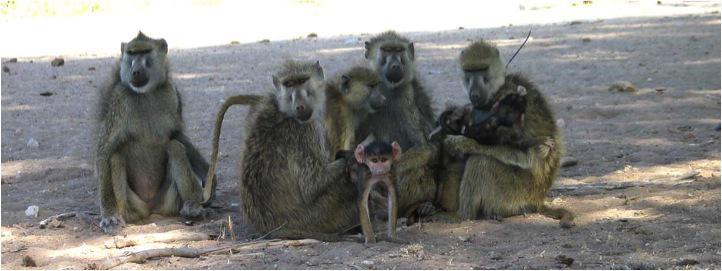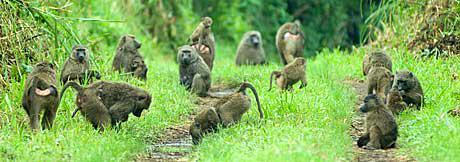The first image is the image on the left, the second image is the image on the right. Considering the images on both sides, is "One image has words." valid? Answer yes or no. No. The first image is the image on the left, the second image is the image on the right. Analyze the images presented: Is the assertion "There are monkeys sitting on grass." valid? Answer yes or no. Yes. 